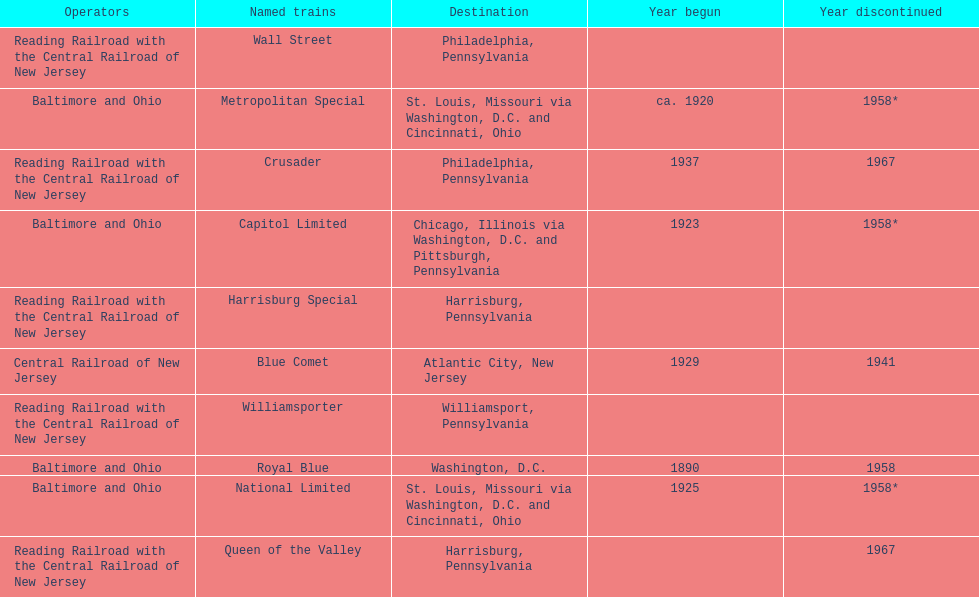What is the difference (in years) between when the royal blue began and the year the crusader began? 47. Can you give me this table as a dict? {'header': ['Operators', 'Named trains', 'Destination', 'Year begun', 'Year discontinued'], 'rows': [['Reading Railroad with the Central Railroad of New Jersey', 'Wall Street', 'Philadelphia, Pennsylvania', '', ''], ['Baltimore and Ohio', 'Metropolitan Special', 'St. Louis, Missouri via Washington, D.C. and Cincinnati, Ohio', 'ca. 1920', '1958*'], ['Reading Railroad with the Central Railroad of New Jersey', 'Crusader', 'Philadelphia, Pennsylvania', '1937', '1967'], ['Baltimore and Ohio', 'Capitol Limited', 'Chicago, Illinois via Washington, D.C. and Pittsburgh, Pennsylvania', '1923', '1958*'], ['Reading Railroad with the Central Railroad of New Jersey', 'Harrisburg Special', 'Harrisburg, Pennsylvania', '', ''], ['Central Railroad of New Jersey', 'Blue Comet', 'Atlantic City, New Jersey', '1929', '1941'], ['Reading Railroad with the Central Railroad of New Jersey', 'Williamsporter', 'Williamsport, Pennsylvania', '', ''], ['Baltimore and Ohio', 'Royal Blue', 'Washington, D.C.', '1890', '1958'], ['Baltimore and Ohio', 'National Limited', 'St. Louis, Missouri via Washington, D.C. and Cincinnati, Ohio', '1925', '1958*'], ['Reading Railroad with the Central Railroad of New Jersey', 'Queen of the Valley', 'Harrisburg, Pennsylvania', '', '1967']]} 